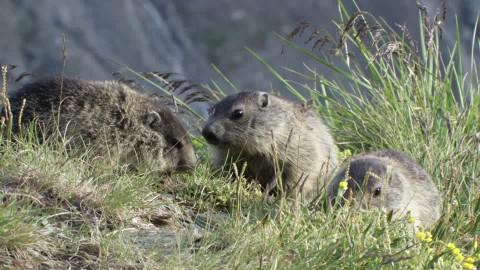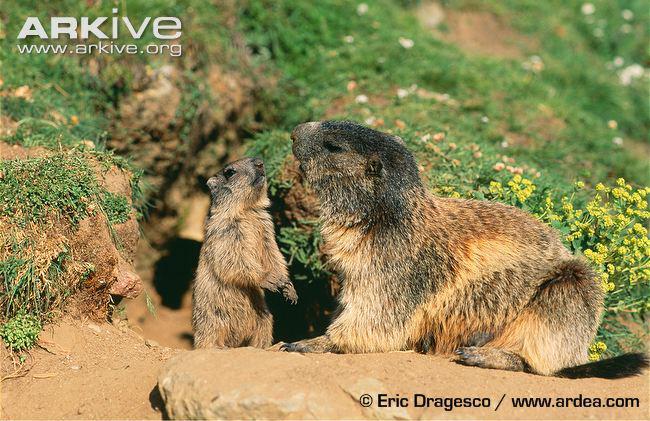The first image is the image on the left, the second image is the image on the right. For the images displayed, is the sentence "The left image contains 3 marmots, and the right image contains 2 marmots." factually correct? Answer yes or no. Yes. The first image is the image on the left, the second image is the image on the right. Examine the images to the left and right. Is the description "There are more animals in the image on the left." accurate? Answer yes or no. Yes. 